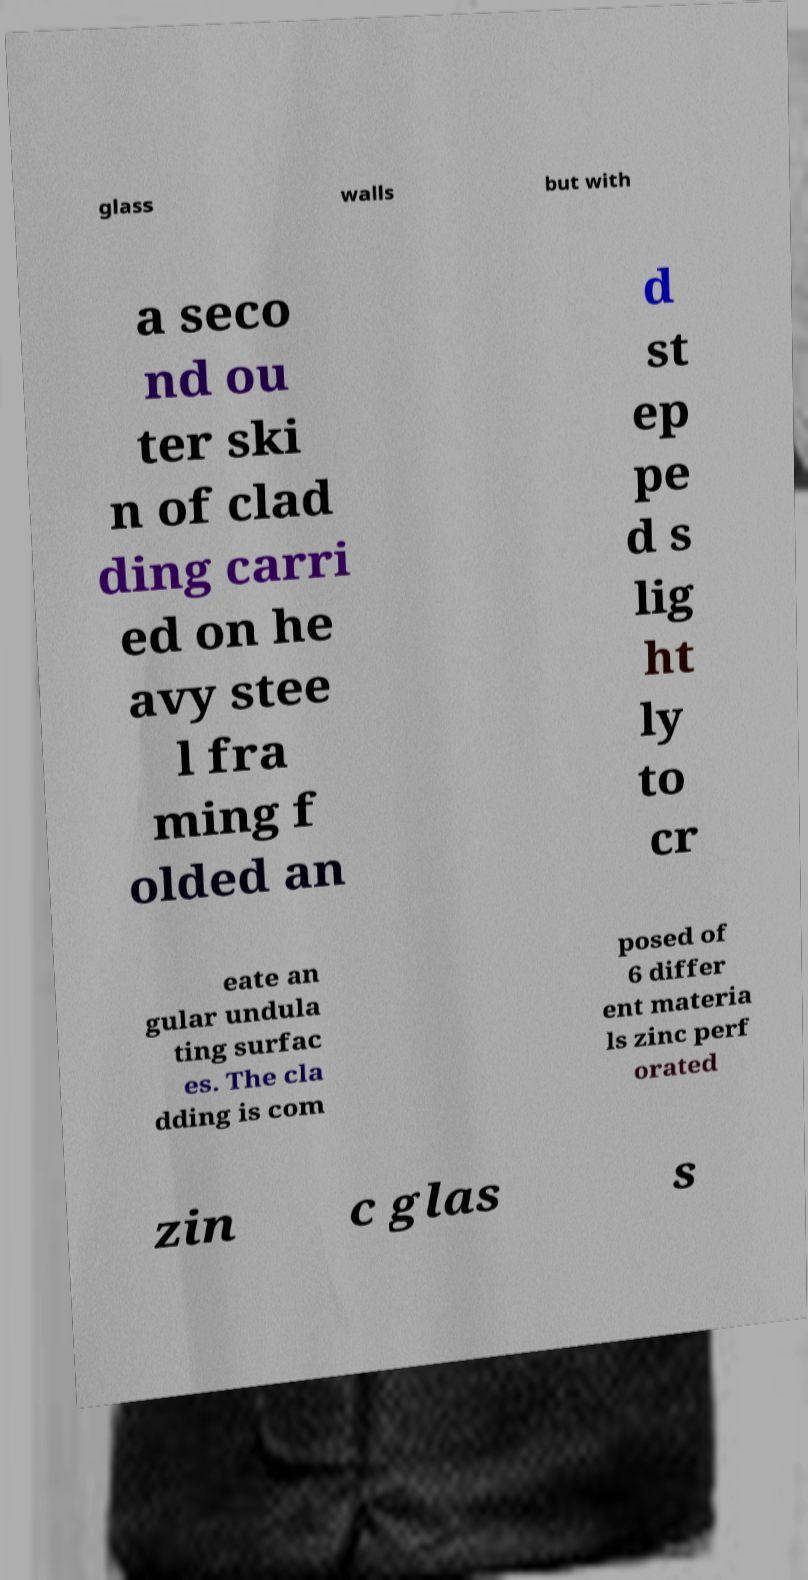I need the written content from this picture converted into text. Can you do that? glass walls but with a seco nd ou ter ski n of clad ding carri ed on he avy stee l fra ming f olded an d st ep pe d s lig ht ly to cr eate an gular undula ting surfac es. The cla dding is com posed of 6 differ ent materia ls zinc perf orated zin c glas s 